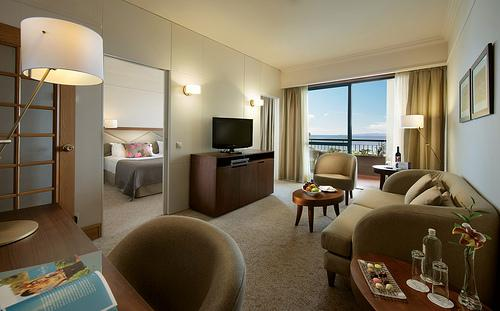Question: what color are the chairs?
Choices:
A. White.
B. Grey.
C. Black.
D. Brown.
Answer with the letter. Answer: D Question: where is the television?
Choices:
A. On the floor.
B. On the counter.
C. In the box.
D. On the stand.
Answer with the letter. Answer: D Question: how many lights are shown?
Choices:
A. Two.
B. Four.
C. Three.
D. Six.
Answer with the letter. Answer: B Question: what is the magazine on?
Choices:
A. The table.
B. The counter.
C. The floor.
D. The porch.
Answer with the letter. Answer: A 